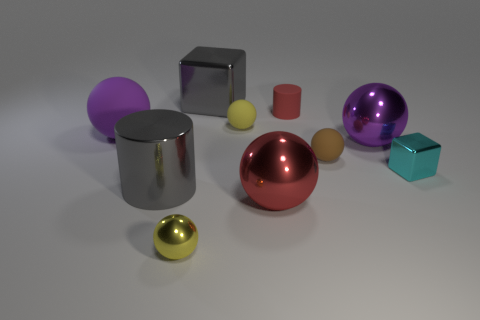Subtract all brown spheres. How many spheres are left? 5 Subtract all purple spheres. How many spheres are left? 4 Subtract all cubes. How many objects are left? 8 Subtract all red balls. Subtract all gray blocks. How many balls are left? 5 Subtract all purple blocks. How many purple spheres are left? 2 Subtract all big shiny objects. Subtract all purple objects. How many objects are left? 4 Add 4 small cyan things. How many small cyan things are left? 5 Add 8 large purple shiny things. How many large purple shiny things exist? 9 Subtract 0 cyan balls. How many objects are left? 10 Subtract 2 cylinders. How many cylinders are left? 0 